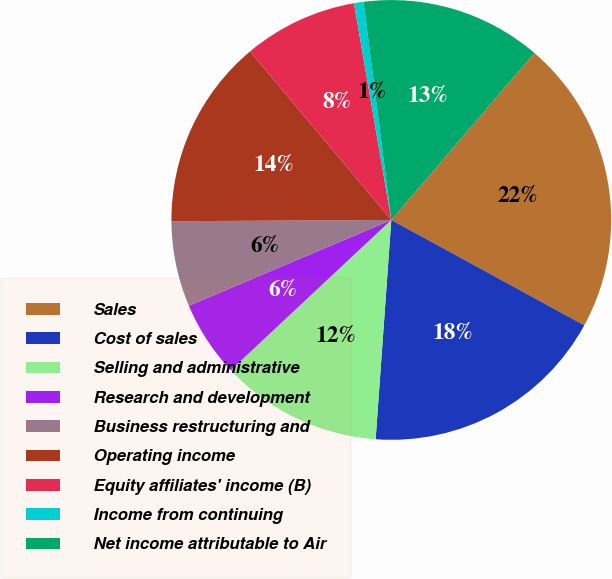Convert chart. <chart><loc_0><loc_0><loc_500><loc_500><pie_chart><fcel>Sales<fcel>Cost of sales<fcel>Selling and administrative<fcel>Research and development<fcel>Business restructuring and<fcel>Operating income<fcel>Equity affiliates' income (B)<fcel>Income from continuing<fcel>Net income attributable to Air<nl><fcel>21.68%<fcel>18.18%<fcel>11.89%<fcel>5.59%<fcel>6.29%<fcel>13.99%<fcel>8.39%<fcel>0.7%<fcel>13.29%<nl></chart> 